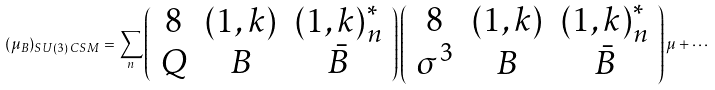Convert formula to latex. <formula><loc_0><loc_0><loc_500><loc_500>( \mu _ { B } ) _ { S U ( 3 ) \, C S M } = \sum _ { n } \left ( \begin{array} { c c c } { 8 } & { ( 1 , k ) } & { ( 1 , k ) } _ { n } ^ { * } \\ Q & B & { \bar { B } } \end{array} \right ) \left ( \begin{array} { c c c } { 8 } & { ( 1 , k ) } & { ( 1 , k ) } _ { n } ^ { * } \\ \sigma ^ { 3 } & B & { \bar { B } } \end{array} \right ) \mu + \cdots</formula> 